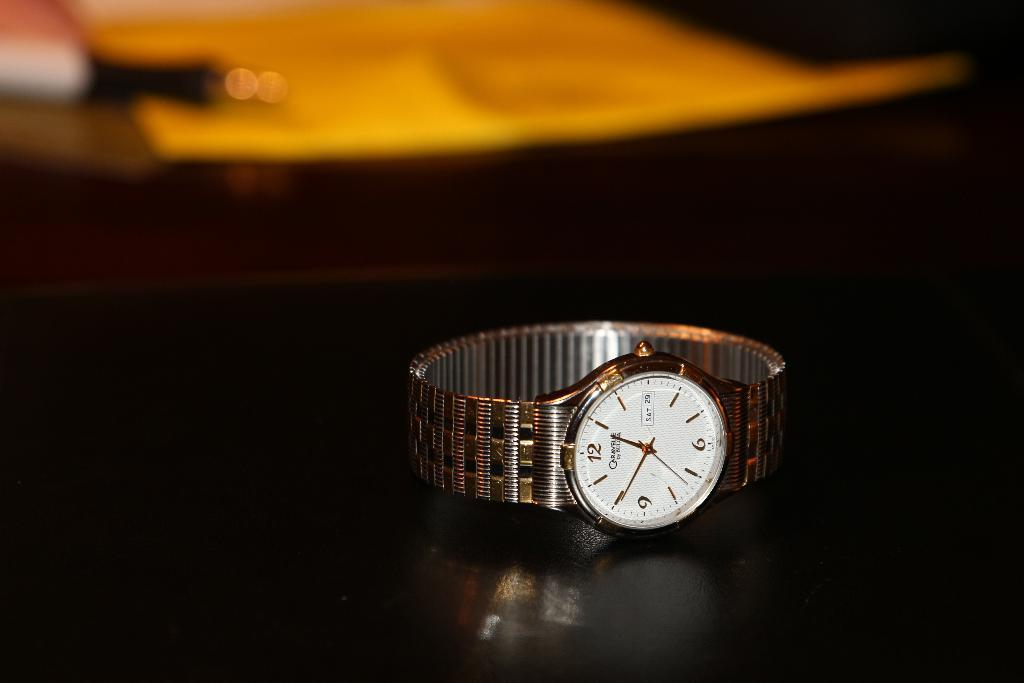What is the main object in the image? There is a wrist watch in the image. What is the wrist watch placed on? The wrist watch is on a black surface. Can you describe the background of the image? The background of the image is blurry. Are there any other objects visible in the image besides the wrist watch? Yes, there are objects in the background of the image. What type of coat is hanging on the tree in the garden in the image? There is no coat or tree in the garden present in the image; it only features a wrist watch on a black surface with a blurry background. 